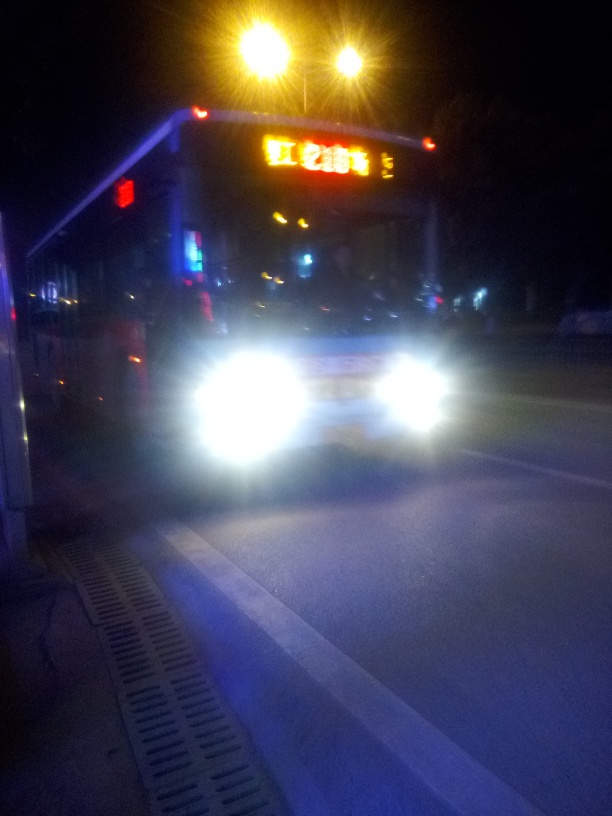How would you describe the sharpness of this image? The sharpness of the image is indeed quite low, characterized by a significant blur that obscures finer details. The primary cause seems to be camera shake or a slow shutter speed, especially noticeable with the overexposure from the vehicle's headlights and taillights, along with the significant loss of detail in the surroundings and text on the sign. 